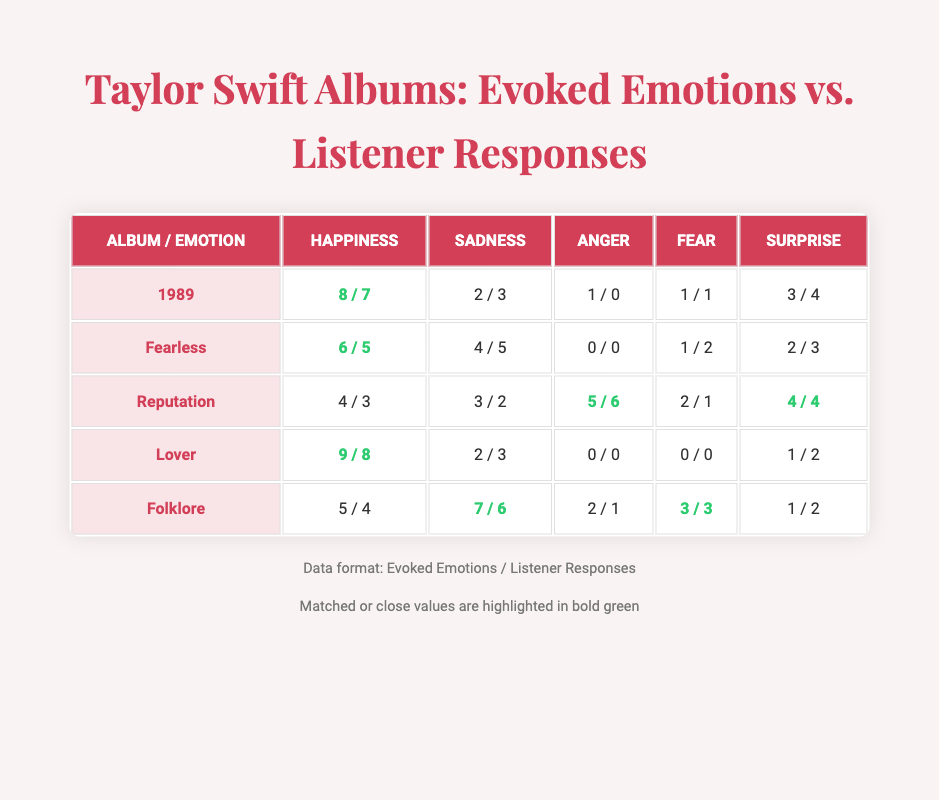What is the evoked emotion with the highest value for the "Lover" album? In the "Lover" album, the evoked emotions are: Happiness (9), Sadness (2), Anger (0), Fear (0), and Surprise (1). The highest value is 9 for Happiness.
Answer: Happiness Which album has the least evoked emotions for Anger? By looking at the Anger row, both "Fearless" and "Lover" have 0 evoked emotions for Anger. Hence, they are the albums with the least evoked emotions for Anger.
Answer: Fearless and Lover What is the total number of Sadness evoked emotions across all albums? To find the total Sadness evoked emotions, add the values from each album: 2 + 4 + 3 + 2 + 7 = 18.
Answer: 18 Is it true that "Reputation" evoked more Anger than the listener responses indicated? "Reputation" evoked 5 emotions of Anger, while the listener responses indicated 6 emotions. Since 6 is greater than 5, it is false that more Anger was evoked than responded to.
Answer: No What is the difference between the maximum and minimum evoked emotions for Surprise across all albums? The maximum value for Surprise is 4 (from "1989" and "Reputation"), and the minimum is 1 (from "Lover" and "Folklore"). The difference is 4 - 1 = 3.
Answer: 3 Which album had the most consensus regarding happiness between evoked emotions and listener responses? The "Lover" album has 9 evoked emotions and 8 listener responses for Happiness, showing a close match. "1989" also had high values (8 evoked vs. 7 responses), but "Lover" has the highest evoked emotion. Thus, "Lover" had the most consensus.
Answer: Lover What are the average listener responses for Fear across all albums? The listener responses for Fear are 1, 2, 1, 0, and 3. Adding these gives 1 + 2 + 1 + 0 + 3 = 7, and dividing by the number of albums (5) yields an average of 7/5 = 1.4.
Answer: 1.4 In "Folklore," did listeners respond with more emotions of Sadness than were evoked? The evoked emotions for Sadness in "Folklore" is 7, while listener responses indicate 6. Since 6 is less than 7, the statement is false.
Answer: No 